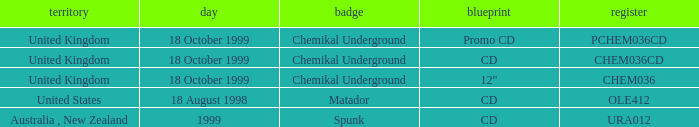What date is associated with the Spunk label? 1999.0. 